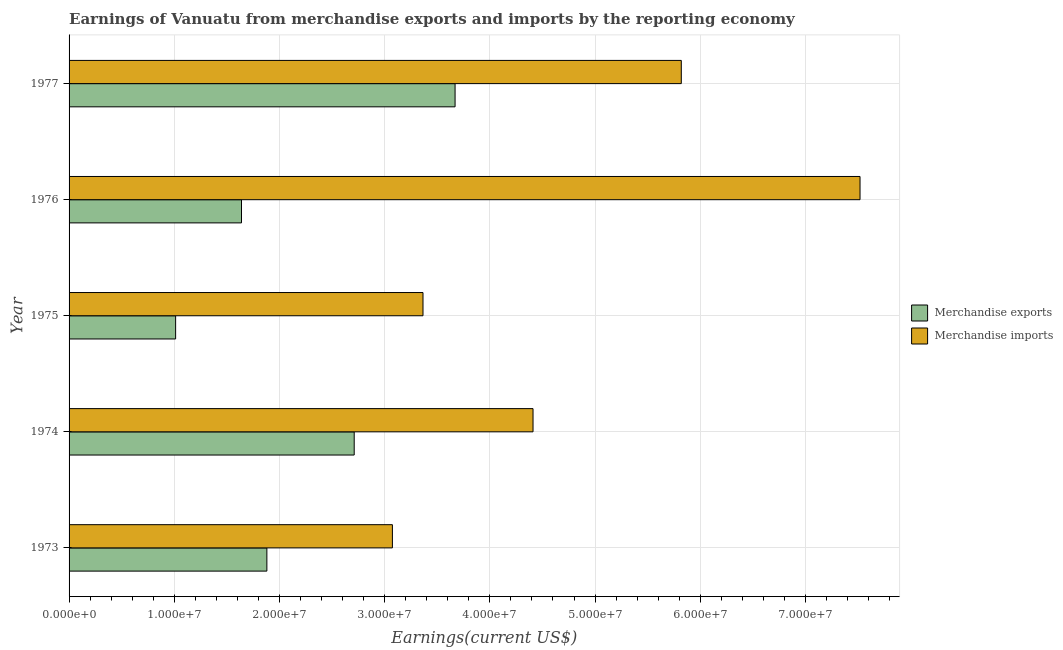Are the number of bars per tick equal to the number of legend labels?
Give a very brief answer. Yes. Are the number of bars on each tick of the Y-axis equal?
Provide a short and direct response. Yes. How many bars are there on the 3rd tick from the bottom?
Give a very brief answer. 2. What is the label of the 1st group of bars from the top?
Keep it short and to the point. 1977. In how many cases, is the number of bars for a given year not equal to the number of legend labels?
Ensure brevity in your answer.  0. What is the earnings from merchandise imports in 1974?
Keep it short and to the point. 4.41e+07. Across all years, what is the maximum earnings from merchandise imports?
Provide a short and direct response. 7.52e+07. Across all years, what is the minimum earnings from merchandise imports?
Ensure brevity in your answer.  3.07e+07. What is the total earnings from merchandise imports in the graph?
Your response must be concise. 2.42e+08. What is the difference between the earnings from merchandise imports in 1974 and that in 1976?
Offer a very short reply. -3.11e+07. What is the difference between the earnings from merchandise imports in 1975 and the earnings from merchandise exports in 1974?
Offer a terse response. 6.54e+06. What is the average earnings from merchandise imports per year?
Make the answer very short. 4.84e+07. In the year 1973, what is the difference between the earnings from merchandise exports and earnings from merchandise imports?
Offer a terse response. -1.19e+07. What is the ratio of the earnings from merchandise imports in 1975 to that in 1976?
Provide a short and direct response. 0.45. Is the earnings from merchandise exports in 1973 less than that in 1977?
Offer a very short reply. Yes. Is the difference between the earnings from merchandise imports in 1973 and 1976 greater than the difference between the earnings from merchandise exports in 1973 and 1976?
Provide a short and direct response. No. What is the difference between the highest and the second highest earnings from merchandise imports?
Keep it short and to the point. 1.70e+07. What is the difference between the highest and the lowest earnings from merchandise imports?
Make the answer very short. 4.45e+07. In how many years, is the earnings from merchandise imports greater than the average earnings from merchandise imports taken over all years?
Offer a terse response. 2. What does the 2nd bar from the bottom in 1977 represents?
Your answer should be very brief. Merchandise imports. What is the difference between two consecutive major ticks on the X-axis?
Your answer should be very brief. 1.00e+07. Are the values on the major ticks of X-axis written in scientific E-notation?
Make the answer very short. Yes. Does the graph contain grids?
Offer a terse response. Yes. How many legend labels are there?
Your answer should be compact. 2. What is the title of the graph?
Your response must be concise. Earnings of Vanuatu from merchandise exports and imports by the reporting economy. What is the label or title of the X-axis?
Your response must be concise. Earnings(current US$). What is the Earnings(current US$) in Merchandise exports in 1973?
Provide a short and direct response. 1.88e+07. What is the Earnings(current US$) of Merchandise imports in 1973?
Your response must be concise. 3.07e+07. What is the Earnings(current US$) of Merchandise exports in 1974?
Give a very brief answer. 2.71e+07. What is the Earnings(current US$) of Merchandise imports in 1974?
Give a very brief answer. 4.41e+07. What is the Earnings(current US$) of Merchandise exports in 1975?
Ensure brevity in your answer.  1.01e+07. What is the Earnings(current US$) in Merchandise imports in 1975?
Offer a terse response. 3.36e+07. What is the Earnings(current US$) in Merchandise exports in 1976?
Your answer should be very brief. 1.64e+07. What is the Earnings(current US$) of Merchandise imports in 1976?
Offer a terse response. 7.52e+07. What is the Earnings(current US$) of Merchandise exports in 1977?
Make the answer very short. 3.67e+07. What is the Earnings(current US$) in Merchandise imports in 1977?
Offer a very short reply. 5.82e+07. Across all years, what is the maximum Earnings(current US$) of Merchandise exports?
Your answer should be very brief. 3.67e+07. Across all years, what is the maximum Earnings(current US$) of Merchandise imports?
Provide a succinct answer. 7.52e+07. Across all years, what is the minimum Earnings(current US$) of Merchandise exports?
Give a very brief answer. 1.01e+07. Across all years, what is the minimum Earnings(current US$) of Merchandise imports?
Provide a short and direct response. 3.07e+07. What is the total Earnings(current US$) in Merchandise exports in the graph?
Your answer should be very brief. 1.09e+08. What is the total Earnings(current US$) in Merchandise imports in the graph?
Offer a terse response. 2.42e+08. What is the difference between the Earnings(current US$) of Merchandise exports in 1973 and that in 1974?
Make the answer very short. -8.30e+06. What is the difference between the Earnings(current US$) of Merchandise imports in 1973 and that in 1974?
Keep it short and to the point. -1.34e+07. What is the difference between the Earnings(current US$) of Merchandise exports in 1973 and that in 1975?
Provide a succinct answer. 8.67e+06. What is the difference between the Earnings(current US$) in Merchandise imports in 1973 and that in 1975?
Give a very brief answer. -2.91e+06. What is the difference between the Earnings(current US$) in Merchandise exports in 1973 and that in 1976?
Your answer should be compact. 2.41e+06. What is the difference between the Earnings(current US$) of Merchandise imports in 1973 and that in 1976?
Ensure brevity in your answer.  -4.45e+07. What is the difference between the Earnings(current US$) in Merchandise exports in 1973 and that in 1977?
Give a very brief answer. -1.79e+07. What is the difference between the Earnings(current US$) of Merchandise imports in 1973 and that in 1977?
Ensure brevity in your answer.  -2.75e+07. What is the difference between the Earnings(current US$) in Merchandise exports in 1974 and that in 1975?
Give a very brief answer. 1.70e+07. What is the difference between the Earnings(current US$) in Merchandise imports in 1974 and that in 1975?
Offer a terse response. 1.05e+07. What is the difference between the Earnings(current US$) in Merchandise exports in 1974 and that in 1976?
Make the answer very short. 1.07e+07. What is the difference between the Earnings(current US$) of Merchandise imports in 1974 and that in 1976?
Ensure brevity in your answer.  -3.11e+07. What is the difference between the Earnings(current US$) in Merchandise exports in 1974 and that in 1977?
Offer a very short reply. -9.59e+06. What is the difference between the Earnings(current US$) of Merchandise imports in 1974 and that in 1977?
Provide a short and direct response. -1.41e+07. What is the difference between the Earnings(current US$) of Merchandise exports in 1975 and that in 1976?
Provide a short and direct response. -6.26e+06. What is the difference between the Earnings(current US$) in Merchandise imports in 1975 and that in 1976?
Your response must be concise. -4.15e+07. What is the difference between the Earnings(current US$) in Merchandise exports in 1975 and that in 1977?
Your answer should be very brief. -2.66e+07. What is the difference between the Earnings(current US$) of Merchandise imports in 1975 and that in 1977?
Offer a terse response. -2.46e+07. What is the difference between the Earnings(current US$) in Merchandise exports in 1976 and that in 1977?
Your answer should be very brief. -2.03e+07. What is the difference between the Earnings(current US$) of Merchandise imports in 1976 and that in 1977?
Offer a terse response. 1.70e+07. What is the difference between the Earnings(current US$) in Merchandise exports in 1973 and the Earnings(current US$) in Merchandise imports in 1974?
Make the answer very short. -2.53e+07. What is the difference between the Earnings(current US$) of Merchandise exports in 1973 and the Earnings(current US$) of Merchandise imports in 1975?
Make the answer very short. -1.48e+07. What is the difference between the Earnings(current US$) of Merchandise exports in 1973 and the Earnings(current US$) of Merchandise imports in 1976?
Provide a short and direct response. -5.64e+07. What is the difference between the Earnings(current US$) of Merchandise exports in 1973 and the Earnings(current US$) of Merchandise imports in 1977?
Your answer should be compact. -3.94e+07. What is the difference between the Earnings(current US$) of Merchandise exports in 1974 and the Earnings(current US$) of Merchandise imports in 1975?
Your answer should be very brief. -6.54e+06. What is the difference between the Earnings(current US$) of Merchandise exports in 1974 and the Earnings(current US$) of Merchandise imports in 1976?
Give a very brief answer. -4.81e+07. What is the difference between the Earnings(current US$) in Merchandise exports in 1974 and the Earnings(current US$) in Merchandise imports in 1977?
Provide a short and direct response. -3.11e+07. What is the difference between the Earnings(current US$) in Merchandise exports in 1975 and the Earnings(current US$) in Merchandise imports in 1976?
Provide a short and direct response. -6.51e+07. What is the difference between the Earnings(current US$) of Merchandise exports in 1975 and the Earnings(current US$) of Merchandise imports in 1977?
Provide a short and direct response. -4.81e+07. What is the difference between the Earnings(current US$) of Merchandise exports in 1976 and the Earnings(current US$) of Merchandise imports in 1977?
Ensure brevity in your answer.  -4.18e+07. What is the average Earnings(current US$) in Merchandise exports per year?
Offer a terse response. 2.18e+07. What is the average Earnings(current US$) in Merchandise imports per year?
Ensure brevity in your answer.  4.84e+07. In the year 1973, what is the difference between the Earnings(current US$) in Merchandise exports and Earnings(current US$) in Merchandise imports?
Offer a very short reply. -1.19e+07. In the year 1974, what is the difference between the Earnings(current US$) of Merchandise exports and Earnings(current US$) of Merchandise imports?
Make the answer very short. -1.70e+07. In the year 1975, what is the difference between the Earnings(current US$) in Merchandise exports and Earnings(current US$) in Merchandise imports?
Offer a very short reply. -2.35e+07. In the year 1976, what is the difference between the Earnings(current US$) in Merchandise exports and Earnings(current US$) in Merchandise imports?
Keep it short and to the point. -5.88e+07. In the year 1977, what is the difference between the Earnings(current US$) in Merchandise exports and Earnings(current US$) in Merchandise imports?
Offer a very short reply. -2.15e+07. What is the ratio of the Earnings(current US$) in Merchandise exports in 1973 to that in 1974?
Provide a short and direct response. 0.69. What is the ratio of the Earnings(current US$) of Merchandise imports in 1973 to that in 1974?
Give a very brief answer. 0.7. What is the ratio of the Earnings(current US$) of Merchandise exports in 1973 to that in 1975?
Offer a very short reply. 1.86. What is the ratio of the Earnings(current US$) in Merchandise imports in 1973 to that in 1975?
Keep it short and to the point. 0.91. What is the ratio of the Earnings(current US$) of Merchandise exports in 1973 to that in 1976?
Make the answer very short. 1.15. What is the ratio of the Earnings(current US$) in Merchandise imports in 1973 to that in 1976?
Your answer should be compact. 0.41. What is the ratio of the Earnings(current US$) of Merchandise exports in 1973 to that in 1977?
Your answer should be compact. 0.51. What is the ratio of the Earnings(current US$) of Merchandise imports in 1973 to that in 1977?
Offer a terse response. 0.53. What is the ratio of the Earnings(current US$) in Merchandise exports in 1974 to that in 1975?
Your answer should be compact. 2.68. What is the ratio of the Earnings(current US$) of Merchandise imports in 1974 to that in 1975?
Provide a succinct answer. 1.31. What is the ratio of the Earnings(current US$) of Merchandise exports in 1974 to that in 1976?
Give a very brief answer. 1.65. What is the ratio of the Earnings(current US$) of Merchandise imports in 1974 to that in 1976?
Make the answer very short. 0.59. What is the ratio of the Earnings(current US$) of Merchandise exports in 1974 to that in 1977?
Offer a very short reply. 0.74. What is the ratio of the Earnings(current US$) of Merchandise imports in 1974 to that in 1977?
Provide a succinct answer. 0.76. What is the ratio of the Earnings(current US$) of Merchandise exports in 1975 to that in 1976?
Ensure brevity in your answer.  0.62. What is the ratio of the Earnings(current US$) of Merchandise imports in 1975 to that in 1976?
Provide a succinct answer. 0.45. What is the ratio of the Earnings(current US$) in Merchandise exports in 1975 to that in 1977?
Make the answer very short. 0.28. What is the ratio of the Earnings(current US$) in Merchandise imports in 1975 to that in 1977?
Your answer should be very brief. 0.58. What is the ratio of the Earnings(current US$) of Merchandise exports in 1976 to that in 1977?
Give a very brief answer. 0.45. What is the ratio of the Earnings(current US$) in Merchandise imports in 1976 to that in 1977?
Make the answer very short. 1.29. What is the difference between the highest and the second highest Earnings(current US$) in Merchandise exports?
Your response must be concise. 9.59e+06. What is the difference between the highest and the second highest Earnings(current US$) in Merchandise imports?
Your answer should be compact. 1.70e+07. What is the difference between the highest and the lowest Earnings(current US$) of Merchandise exports?
Ensure brevity in your answer.  2.66e+07. What is the difference between the highest and the lowest Earnings(current US$) in Merchandise imports?
Keep it short and to the point. 4.45e+07. 